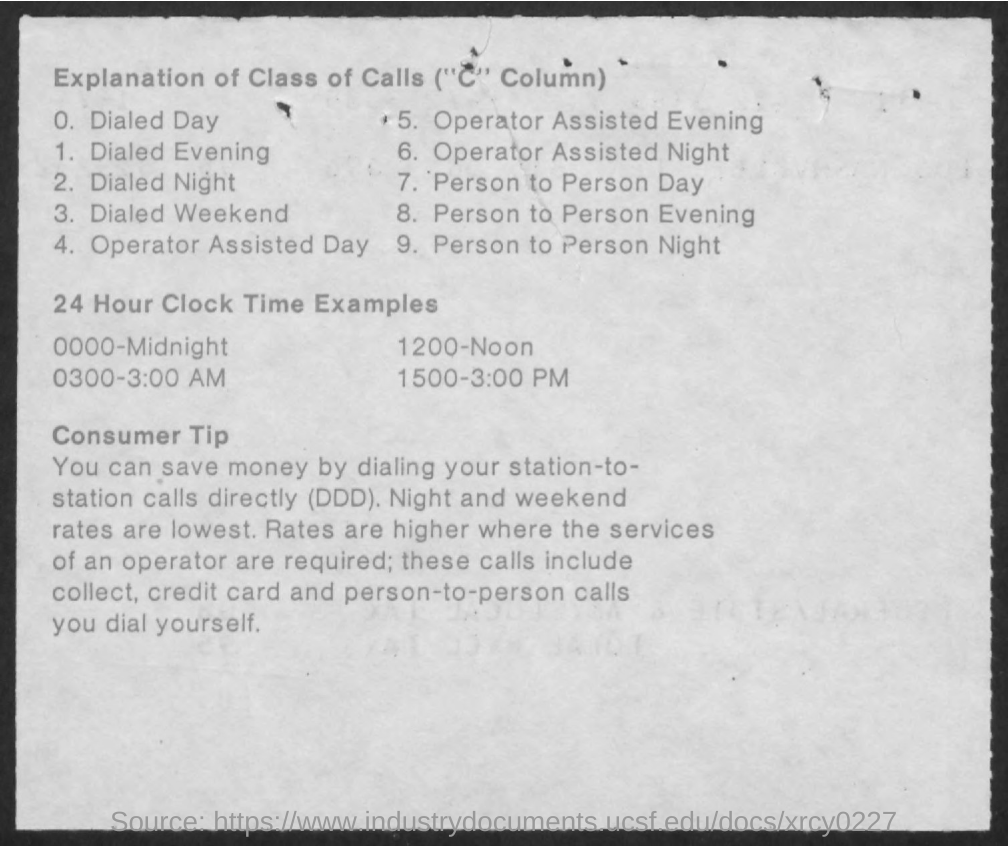What does 0000 represents in the 24 hour clock as shown in the given page ?
Offer a very short reply. Midnight. What does 1200 stands in 24 hour clock  as per the given page ?
Your answer should be very brief. Noon. What does 0300 represents in the 24 hour clock as given in the page ?
Make the answer very short. 3:00 AM. What does 1500 represents in the 24 hour clock as shown in the given page ?
Your answer should be compact. 3:00 PM. 